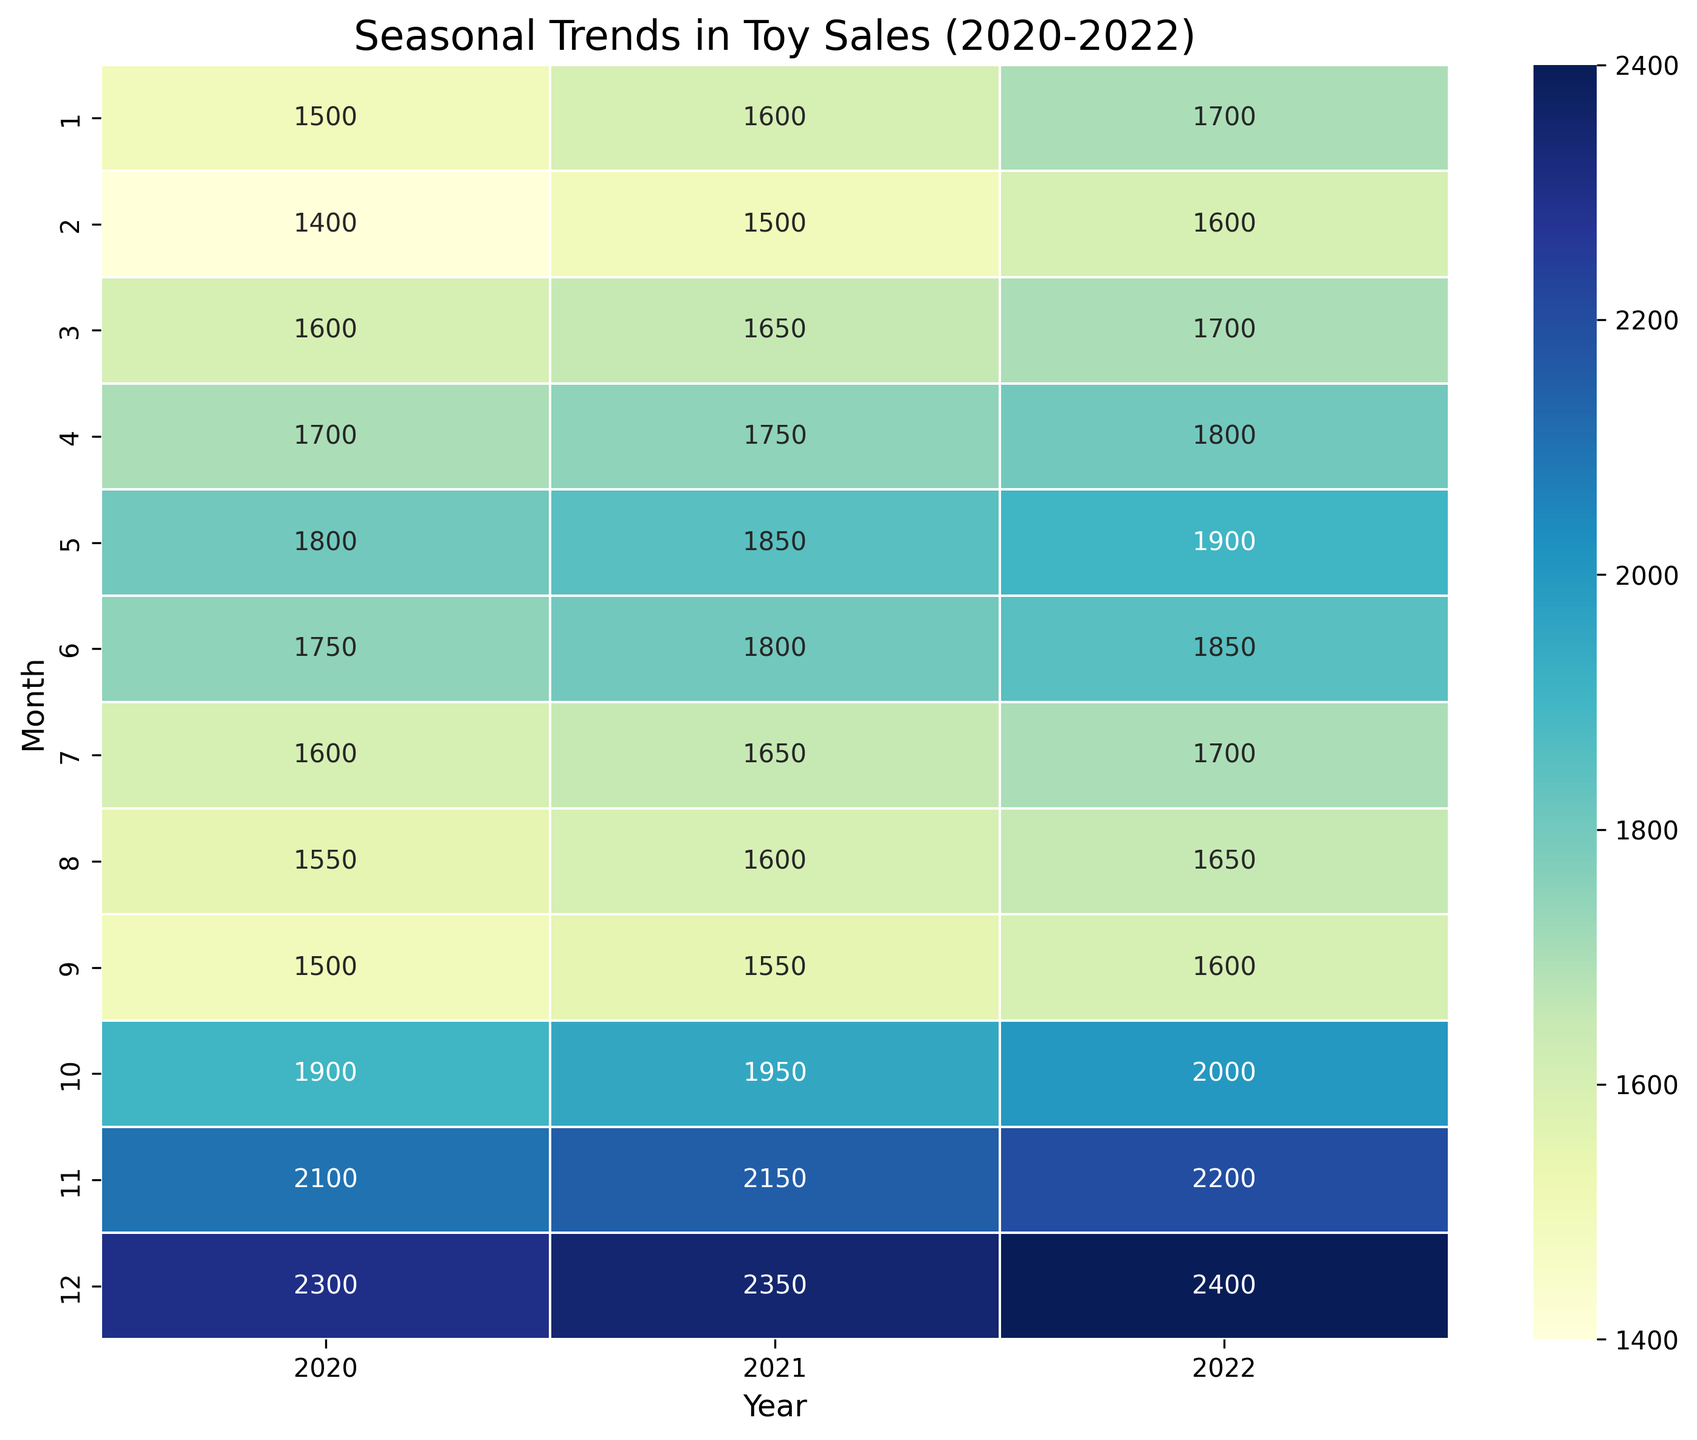Which month across all years has the highest toy sales? To determine the month with the highest toy sales across all years, look for the darkest colored cell in the heatmap. The darkest cell is located in December in all years, indicating it has the highest sales figures.
Answer: December Which year had the highest average toy sales in November? Compare the color intensity of the cells corresponding to November for each year. The cell with the darkest color represents the highest average sales. November 2022 has the darkest shade, indicating it had the highest average sales.
Answer: 2022 What is the average toy sales in July for the years 2020 and 2021? Check the values in the cell corresponding to July for both years. For 2020, it is 1600, and for 2021, it is 1650. Average these values: (1600 + 1650) / 2 = 1625.
Answer: 1625 Which month shows the lowest average rarity level across the three years? The month with the lowest average rarity level will correspond with the lighter shaded cells in the heatmap. Check each month for the lightest color over the years and identify its value. June consistently shows lighter shades indicating lower rarity levels.
Answer: June In which month of 2021 did toy sales see a significant increase compared to the previous month? Compare the value difference for consecutive months in 2021. Noticeable jumps in cell values indicate significant increases. The biggest jump is from September (1550) to October (1950).
Answer: October Which months have an average sales value of over 2000 in 2022? Look at the cells for 2022 and identify those with values over 2000. The months meeting this criterion are November (2200) and December (2400).
Answer: November, December How do the average toy sales in May compare between 2020 and 2022? Check the sales values for May in both 2020 and 2022. In 2020, the value is 1800, and in 2022, it is 1900. 1900 (2022) is higher than 1800 (2020).
Answer: 2022 is higher What is the color indication for the average toy sales in October 2020, and how does it compare with October 2021? Compare the color intensity in October for both years. October 2020 has a lighter color with a sales value of 1900, whereas October 2021 has a darker color with a value of 1950, indicating October 2021 has higher sales.
Answer: October 2021 is higher Is there a visible trend in toy sales leading up to the end of the year for any particular year? Check the color intensity pattern from January to December for each year. Each year shows a gradient from lighter to darker indicating increasing sales moving towards December. This trend is visible in 2020, 2021, and 2022.
Answer: Yes, increasing trend 